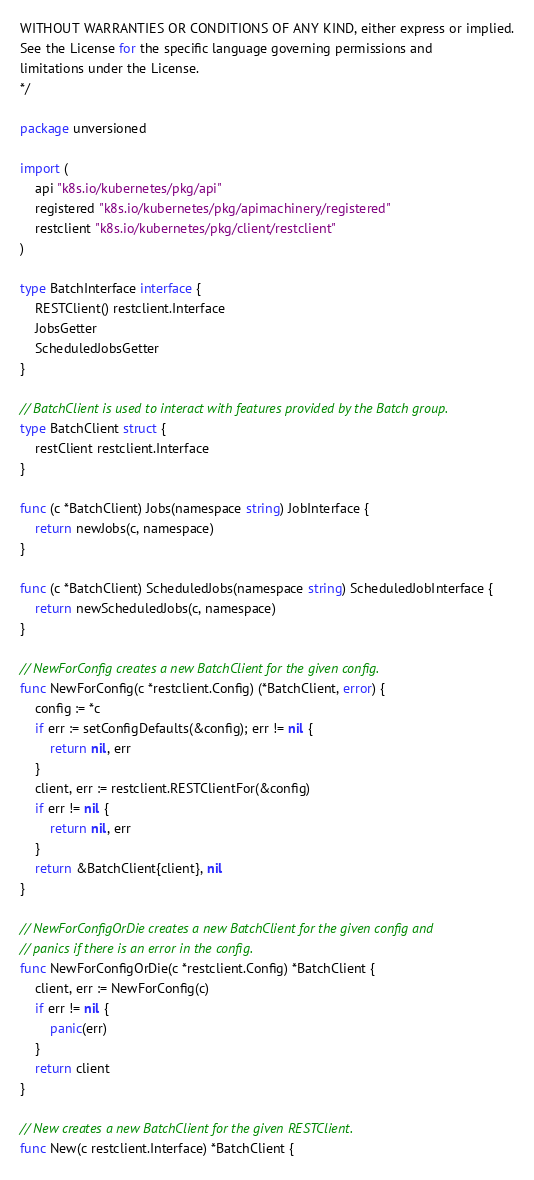Convert code to text. <code><loc_0><loc_0><loc_500><loc_500><_Go_>WITHOUT WARRANTIES OR CONDITIONS OF ANY KIND, either express or implied.
See the License for the specific language governing permissions and
limitations under the License.
*/

package unversioned

import (
	api "k8s.io/kubernetes/pkg/api"
	registered "k8s.io/kubernetes/pkg/apimachinery/registered"
	restclient "k8s.io/kubernetes/pkg/client/restclient"
)

type BatchInterface interface {
	RESTClient() restclient.Interface
	JobsGetter
	ScheduledJobsGetter
}

// BatchClient is used to interact with features provided by the Batch group.
type BatchClient struct {
	restClient restclient.Interface
}

func (c *BatchClient) Jobs(namespace string) JobInterface {
	return newJobs(c, namespace)
}

func (c *BatchClient) ScheduledJobs(namespace string) ScheduledJobInterface {
	return newScheduledJobs(c, namespace)
}

// NewForConfig creates a new BatchClient for the given config.
func NewForConfig(c *restclient.Config) (*BatchClient, error) {
	config := *c
	if err := setConfigDefaults(&config); err != nil {
		return nil, err
	}
	client, err := restclient.RESTClientFor(&config)
	if err != nil {
		return nil, err
	}
	return &BatchClient{client}, nil
}

// NewForConfigOrDie creates a new BatchClient for the given config and
// panics if there is an error in the config.
func NewForConfigOrDie(c *restclient.Config) *BatchClient {
	client, err := NewForConfig(c)
	if err != nil {
		panic(err)
	}
	return client
}

// New creates a new BatchClient for the given RESTClient.
func New(c restclient.Interface) *BatchClient {</code> 